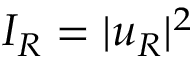Convert formula to latex. <formula><loc_0><loc_0><loc_500><loc_500>I _ { R } = | u _ { R } | ^ { 2 }</formula> 